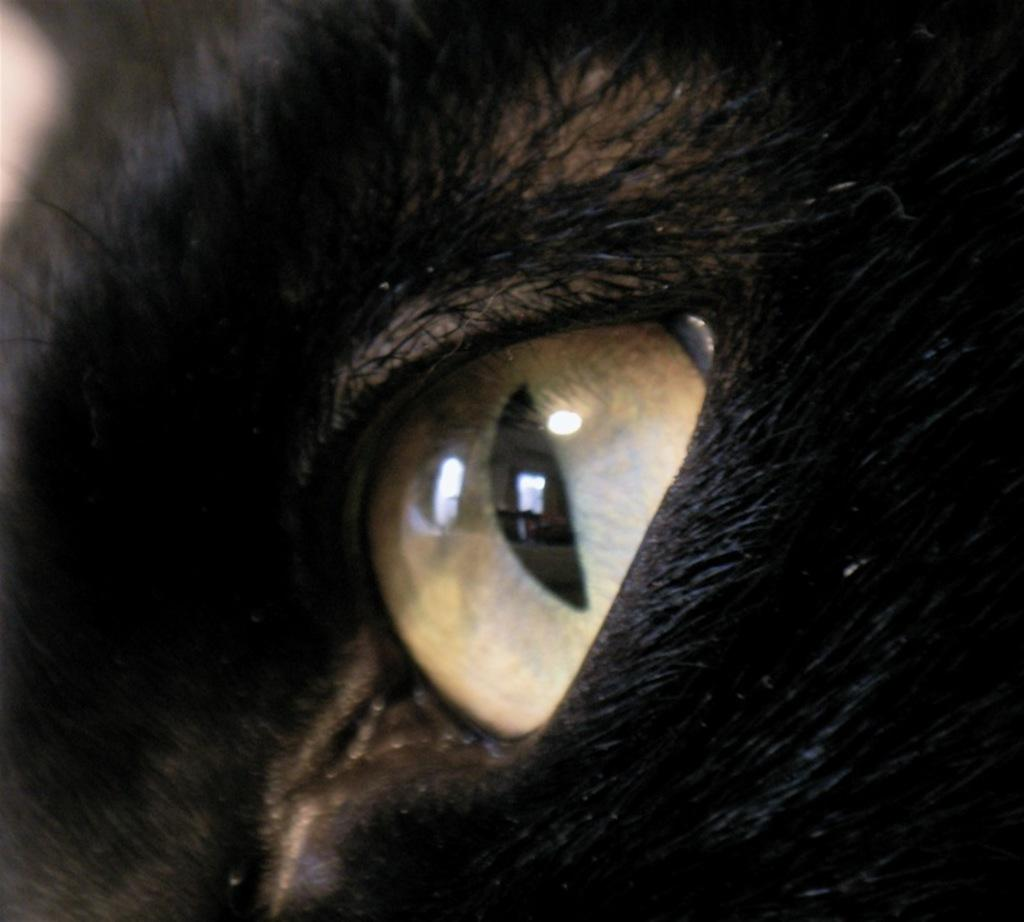What type of living creature is in the image? There is an animal in the image. Can you describe the color of the animal? The animal is black in color. What type of pancake is being served on the ground in the image? There is no pancake or ground present in the image; it only features a black animal. How many ears does the animal have in the image? The number of ears cannot be determined from the image, as only the animal's color is mentioned in the provided facts. 